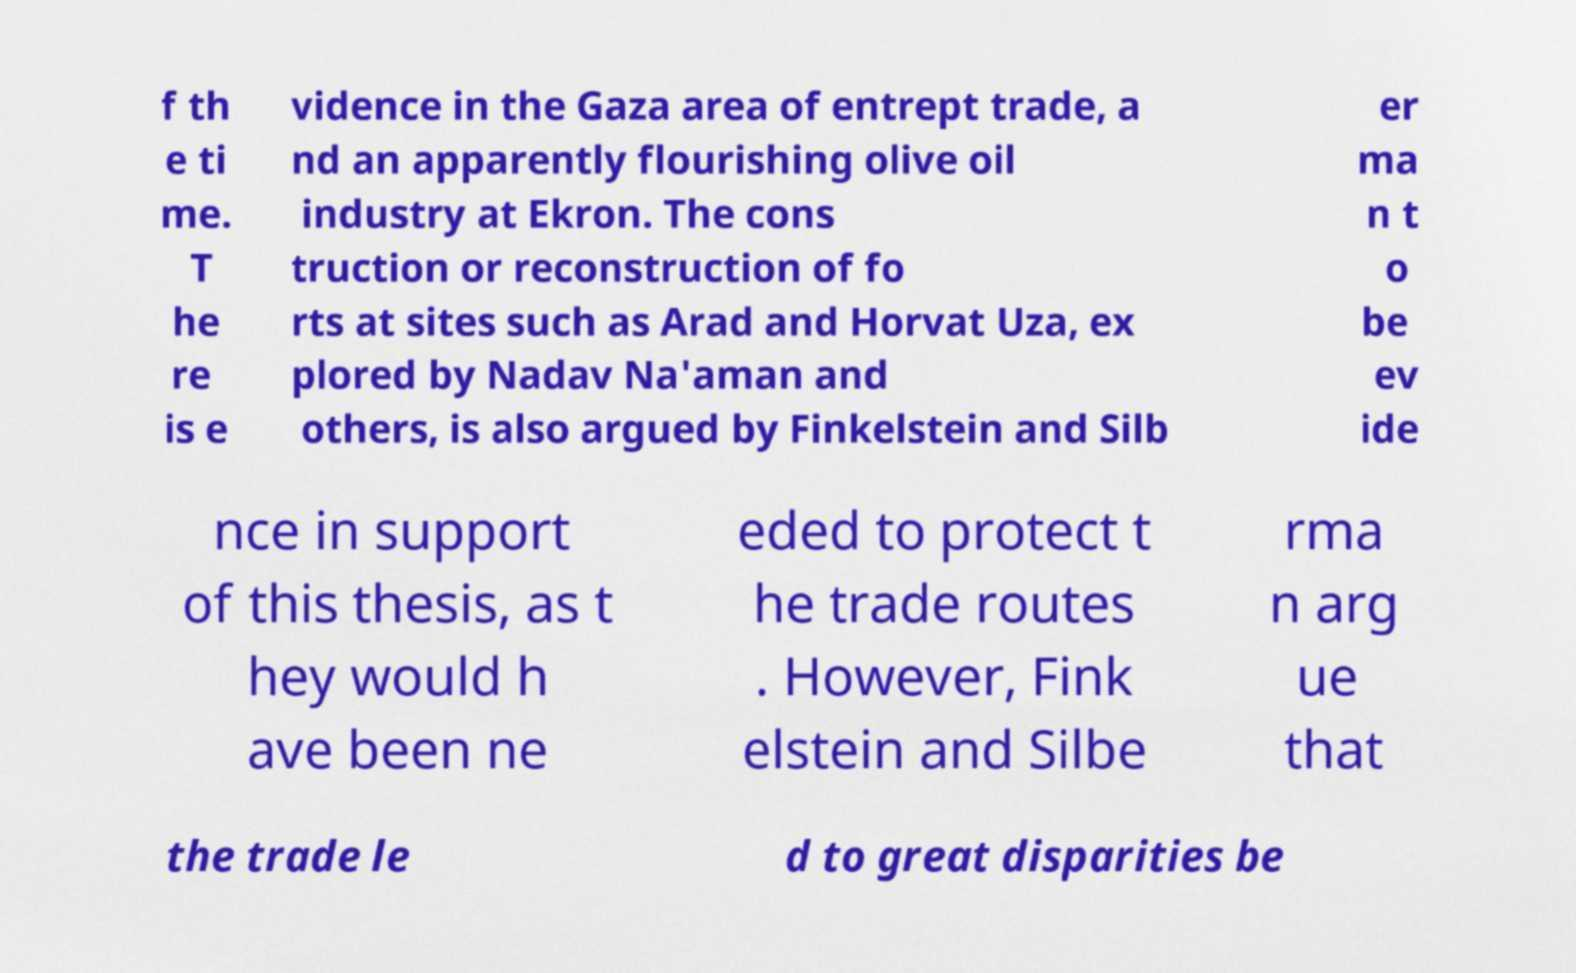There's text embedded in this image that I need extracted. Can you transcribe it verbatim? f th e ti me. T he re is e vidence in the Gaza area of entrept trade, a nd an apparently flourishing olive oil industry at Ekron. The cons truction or reconstruction of fo rts at sites such as Arad and Horvat Uza, ex plored by Nadav Na'aman and others, is also argued by Finkelstein and Silb er ma n t o be ev ide nce in support of this thesis, as t hey would h ave been ne eded to protect t he trade routes . However, Fink elstein and Silbe rma n arg ue that the trade le d to great disparities be 